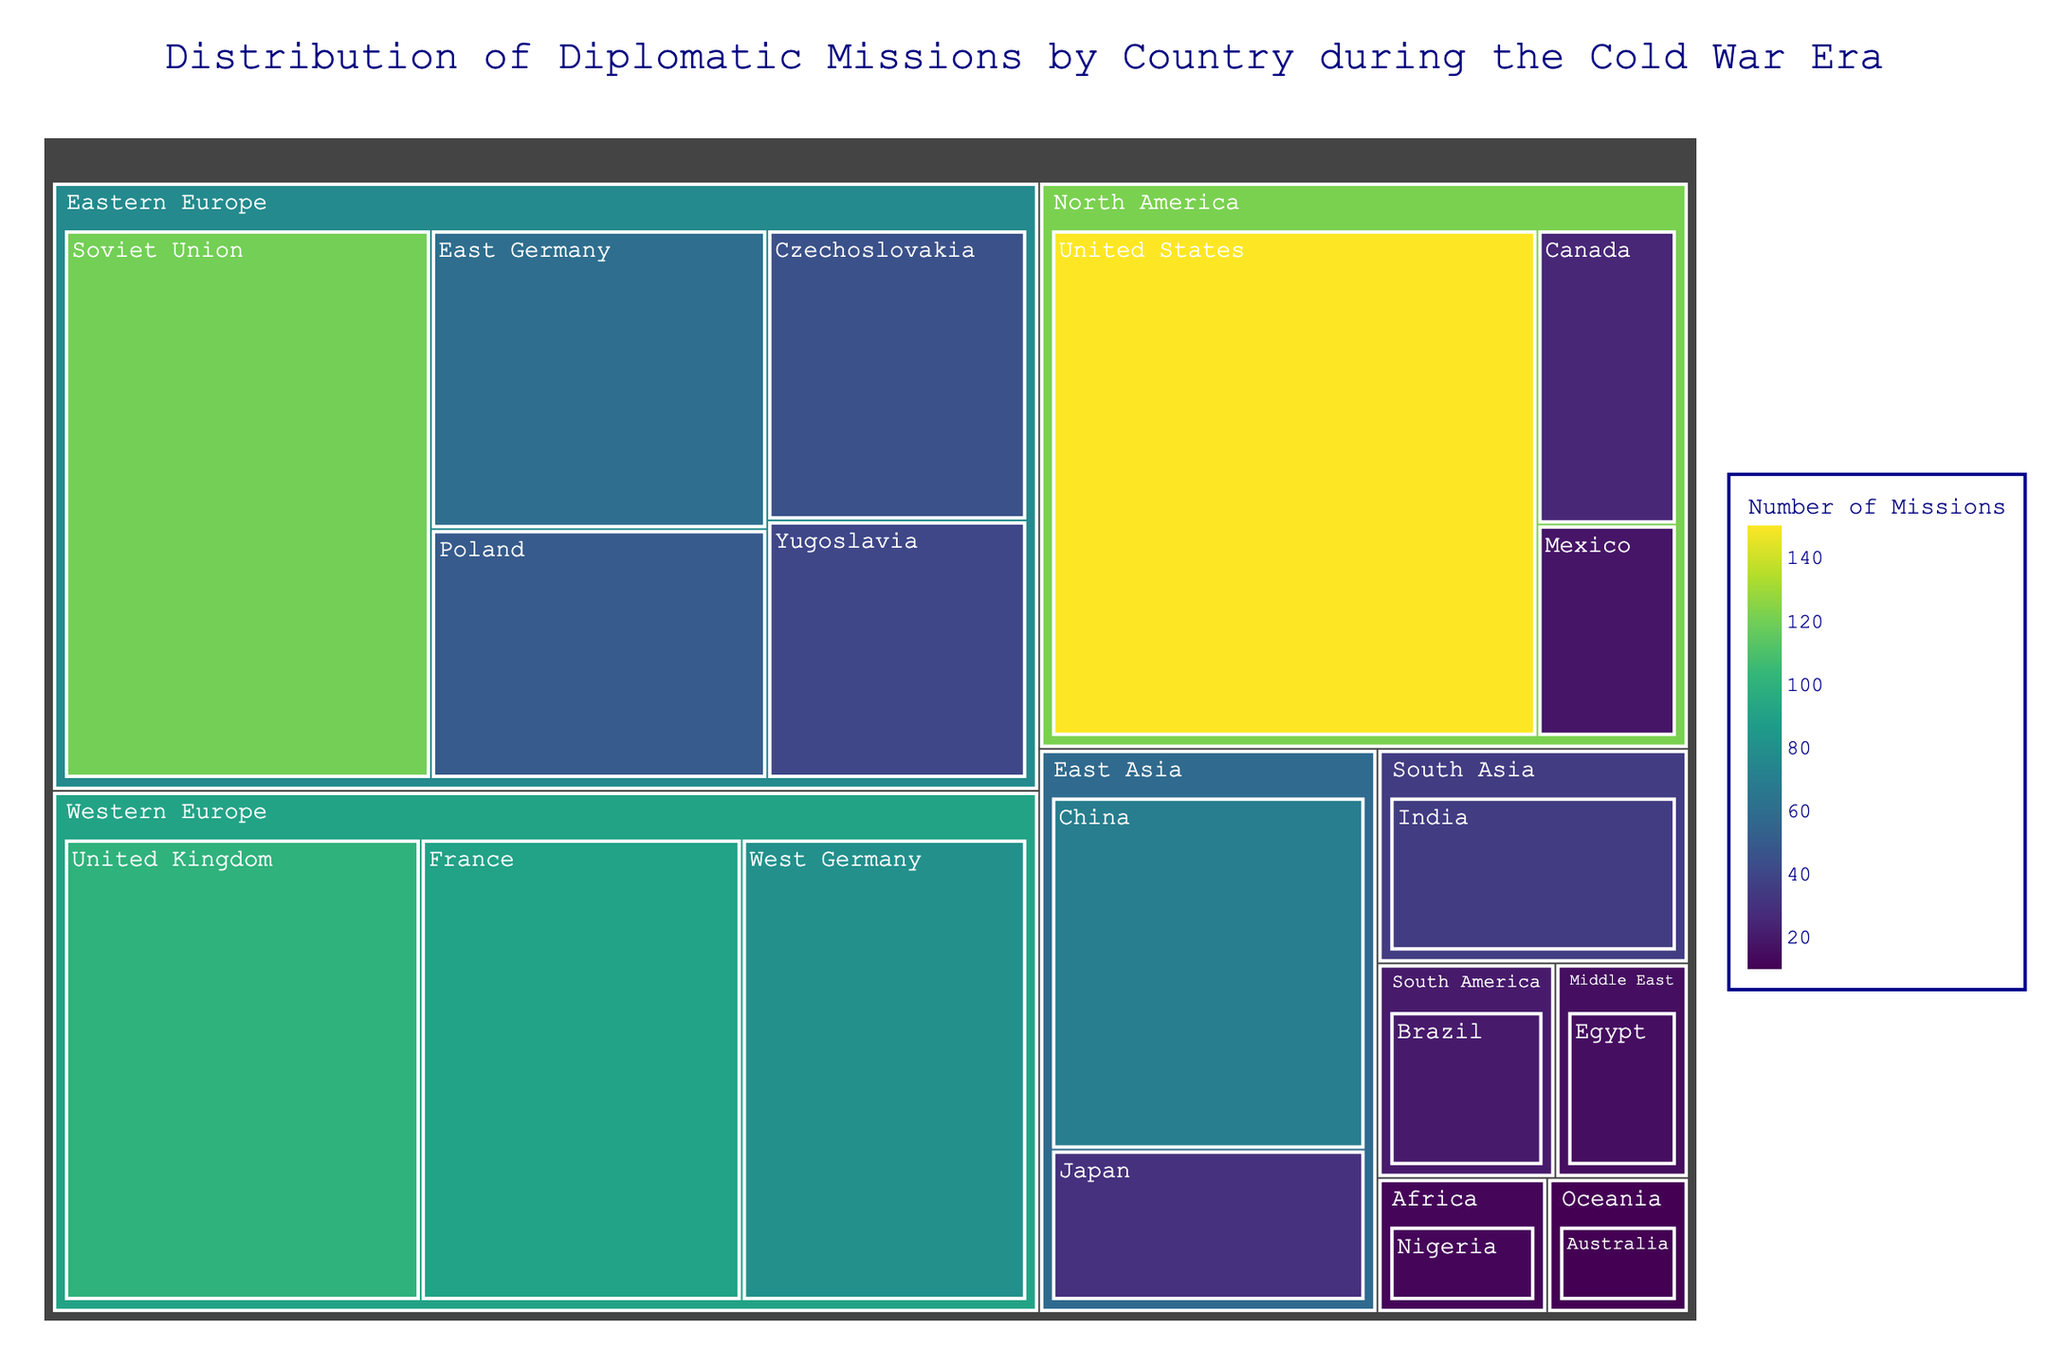What is the title of the treemap? The title is usually displayed prominently at the top of the treemap and provides a summary of what the data represents.
Answer: Distribution of Diplomatic Missions by Country during the Cold War Era Which country has the highest number of diplomatic missions? The country with the largest box and highest value in the treemap indicates the highest number of diplomatic missions.
Answer: United States How many diplomatic missions does France have? Locate France in the treemap and check the number displayed within its box.
Answer: 90 What is the sum of diplomatic missions for the countries in Western Europe? Add the values of the diplomatic missions for all countries within the Western Europe region: United Kingdom (100), France (90), and West Germany (80). 100 + 90 + 80 = 270
Answer: 270 Which continent has the country with the fewest diplomatic missions, and what is that country? Identify the country with the smallest value in the treemap, then refer to its region to determine the continent.
Answer: Oceania, Australia Are there more diplomatic missions in North America or East Asia? Compare the total number of missions for countries in North America (United States: 150, Canada: 25, Mexico: 18) to those in East Asia (China: 70, Japan: 30). North America: 150 + 25 + 18 = 193; East Asia: 70 + 30 = 100
Answer: North America How many diplomatic missions are there in the Middle East? Locate the value of the country in the Middle East region (Egypt) within the treemap.
Answer: 15 Which country in Eastern Europe has fewer diplomatic missions, East Germany or Poland? Compare the number of missions for East Germany and Poland in the treemap.
Answer: Poland What is the average number of diplomatic missions for countries in the treemap? Find the total number of diplomatic missions and divide by the number of countries: (150+120+100+90+80+70+60+50+45+40+35+30+25+20+18+15+12+10) / 18 = 970 / 18 ≈ 53.89
Answer: ≈ 53.89 Which country in South America has 20 diplomatic missions? Locate the value 20 on the treemap corresponding to the South America region.
Answer: Brazil 